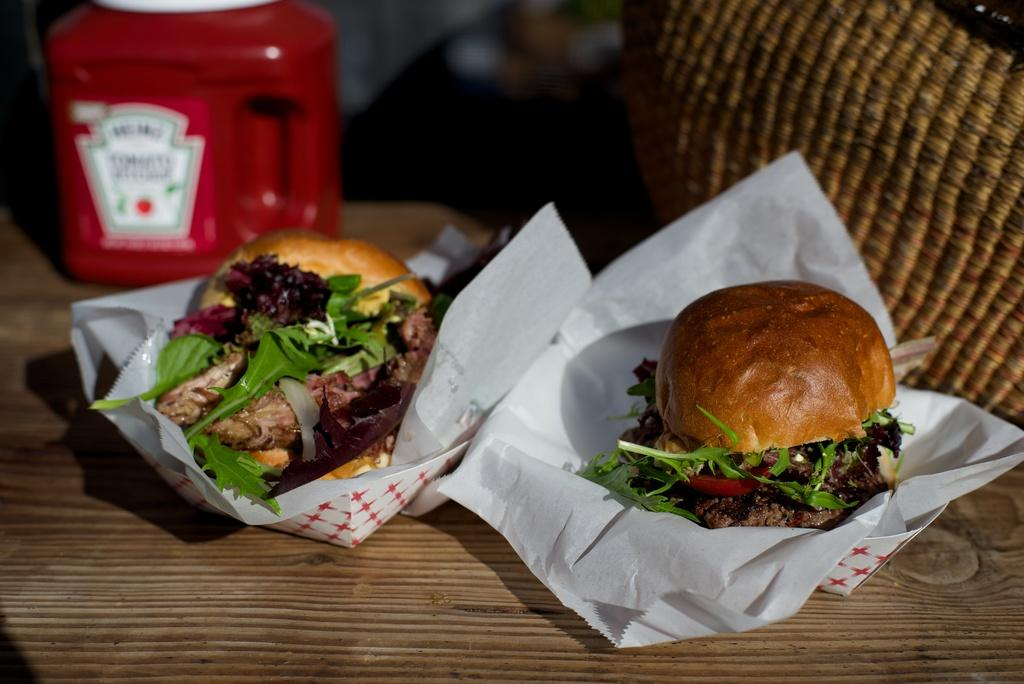What type of food can be seen in the image? There are two burgers in the image. What else is present on the table besides the burgers? There is a basket and a bottle in the image. How are the items arranged in the image? All items are arranged on a table. What type of behavior does the giraffe exhibit in the image? There is no giraffe present in the image, so it is not possible to discuss its behavior. 